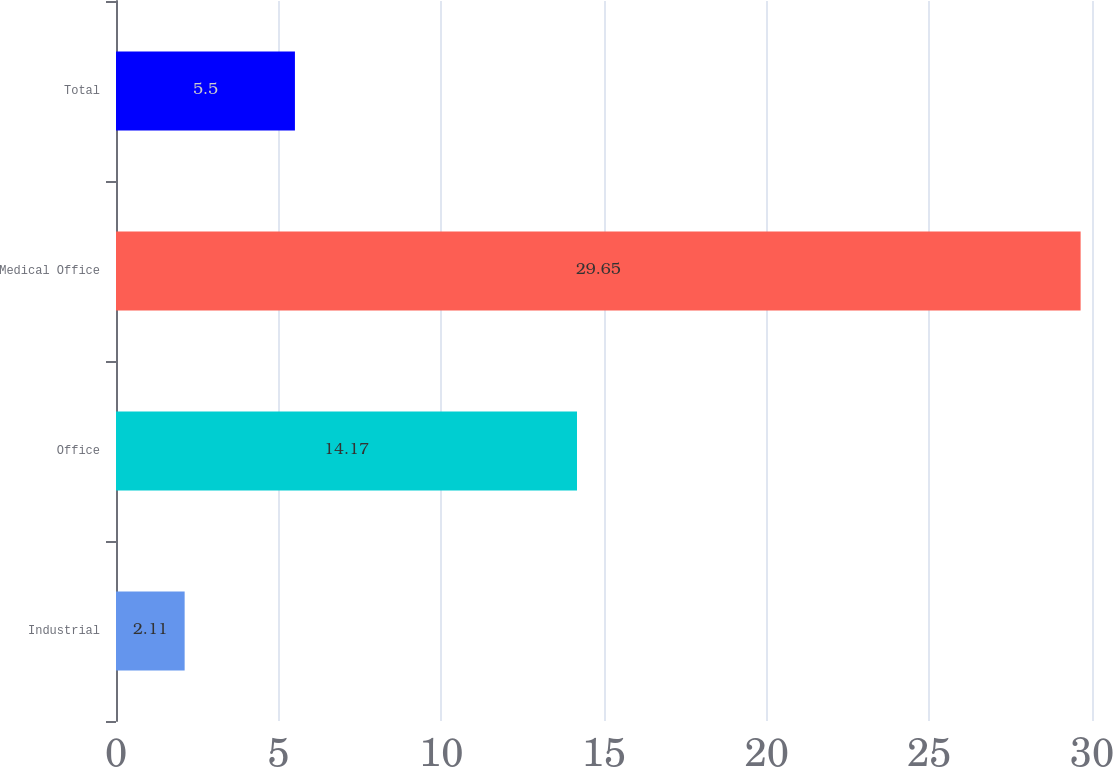Convert chart to OTSL. <chart><loc_0><loc_0><loc_500><loc_500><bar_chart><fcel>Industrial<fcel>Office<fcel>Medical Office<fcel>Total<nl><fcel>2.11<fcel>14.17<fcel>29.65<fcel>5.5<nl></chart> 